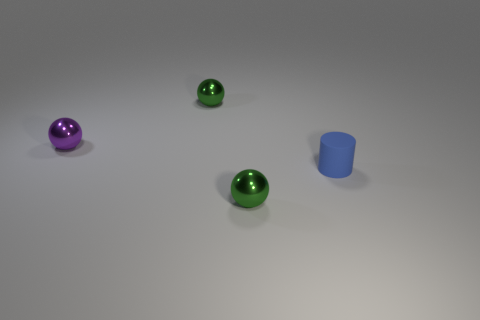Add 4 small yellow cylinders. How many objects exist? 8 Subtract all cylinders. How many objects are left? 3 Add 3 blue things. How many blue things are left? 4 Add 4 purple metal objects. How many purple metal objects exist? 5 Subtract 0 red cylinders. How many objects are left? 4 Subtract all green balls. Subtract all green metallic objects. How many objects are left? 0 